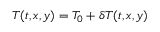Convert formula to latex. <formula><loc_0><loc_0><loc_500><loc_500>T ( t , x , y ) = T _ { 0 } + \delta T ( t , x , y )</formula> 